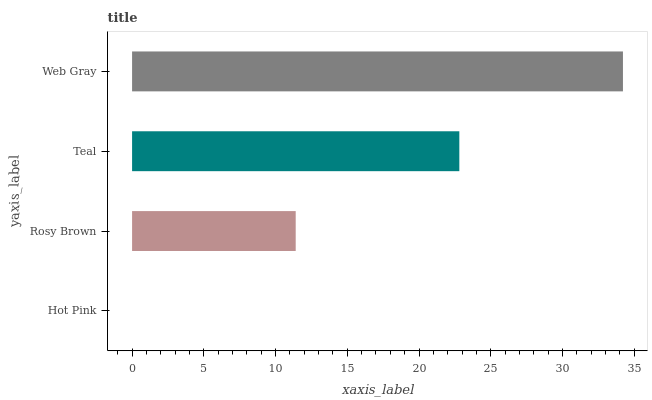Is Hot Pink the minimum?
Answer yes or no. Yes. Is Web Gray the maximum?
Answer yes or no. Yes. Is Rosy Brown the minimum?
Answer yes or no. No. Is Rosy Brown the maximum?
Answer yes or no. No. Is Rosy Brown greater than Hot Pink?
Answer yes or no. Yes. Is Hot Pink less than Rosy Brown?
Answer yes or no. Yes. Is Hot Pink greater than Rosy Brown?
Answer yes or no. No. Is Rosy Brown less than Hot Pink?
Answer yes or no. No. Is Teal the high median?
Answer yes or no. Yes. Is Rosy Brown the low median?
Answer yes or no. Yes. Is Rosy Brown the high median?
Answer yes or no. No. Is Web Gray the low median?
Answer yes or no. No. 